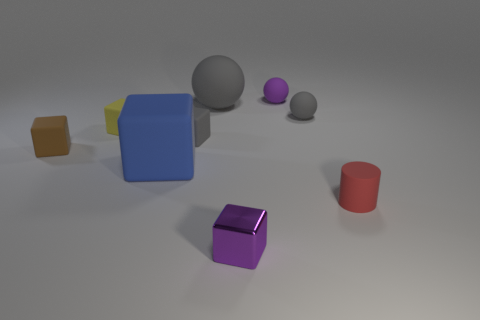Is the color of the tiny rubber cube to the right of the yellow matte thing the same as the large thing right of the large blue rubber cube?
Provide a succinct answer. Yes. What is the shape of the gray thing to the right of the purple matte thing right of the tiny gray matte cube?
Give a very brief answer. Sphere. What number of other things are there of the same color as the tiny metallic object?
Offer a very short reply. 1. Do the purple cube to the left of the tiny gray ball and the purple thing that is behind the blue cube have the same material?
Ensure brevity in your answer.  No. There is a gray rubber sphere that is to the left of the purple rubber thing; what is its size?
Give a very brief answer. Large. There is another gray thing that is the same shape as the tiny metal thing; what is it made of?
Your answer should be compact. Rubber. There is a small purple object left of the purple sphere; what is its shape?
Ensure brevity in your answer.  Cube. What number of rubber objects have the same shape as the tiny purple metallic thing?
Make the answer very short. 4. Are there an equal number of purple things left of the small metal thing and blue matte cubes that are on the left side of the red object?
Offer a terse response. No. Are there any tiny brown cubes that have the same material as the tiny red cylinder?
Provide a succinct answer. Yes. 